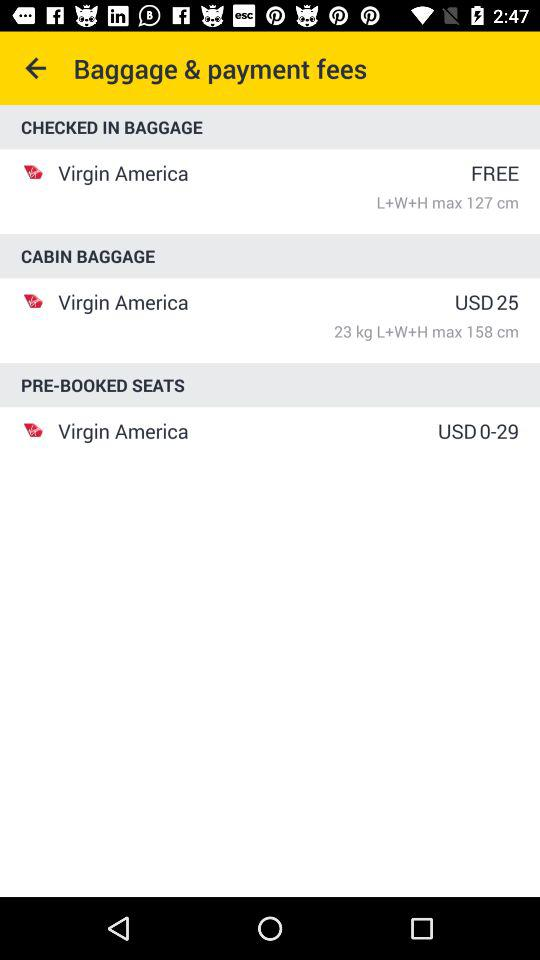What is the airline's name? The airline's name is "Virgin America". 